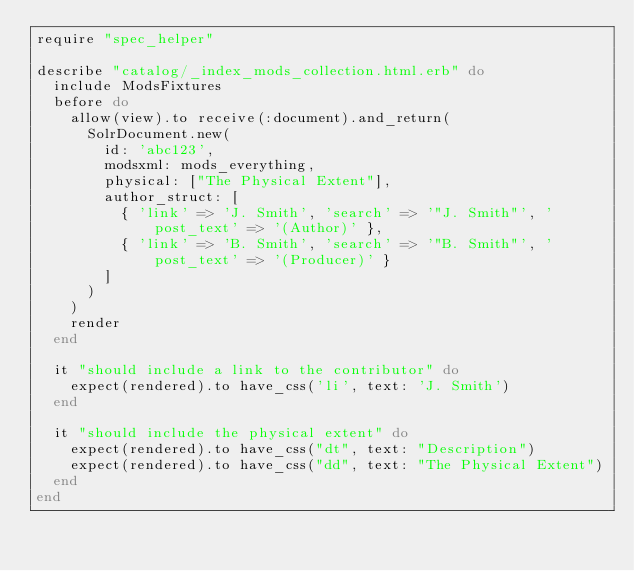<code> <loc_0><loc_0><loc_500><loc_500><_Ruby_>require "spec_helper"

describe "catalog/_index_mods_collection.html.erb" do
  include ModsFixtures
  before do
    allow(view).to receive(:document).and_return(
      SolrDocument.new(
        id: 'abc123',
        modsxml: mods_everything,
        physical: ["The Physical Extent"],
        author_struct: [
          { 'link' => 'J. Smith', 'search' => '"J. Smith"', 'post_text' => '(Author)' },
          { 'link' => 'B. Smith', 'search' => '"B. Smith"', 'post_text' => '(Producer)' }
        ]
      )
    )
    render
  end

  it "should include a link to the contributor" do
    expect(rendered).to have_css('li', text: 'J. Smith')
  end

  it "should include the physical extent" do
    expect(rendered).to have_css("dt", text: "Description")
    expect(rendered).to have_css("dd", text: "The Physical Extent")
  end
end
</code> 